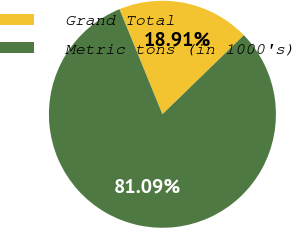Convert chart to OTSL. <chart><loc_0><loc_0><loc_500><loc_500><pie_chart><fcel>Grand Total<fcel>Metric tons (in 1000's)<nl><fcel>18.91%<fcel>81.09%<nl></chart> 